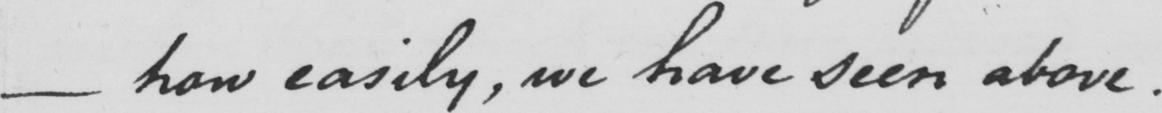What is written in this line of handwriting? _ how easily , we have seen above . 